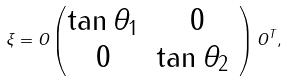Convert formula to latex. <formula><loc_0><loc_0><loc_500><loc_500>\xi = O \begin{pmatrix} \tan \theta _ { 1 } & 0 \\ 0 & \tan \theta _ { 2 } \ \end{pmatrix} O ^ { T } ,</formula> 